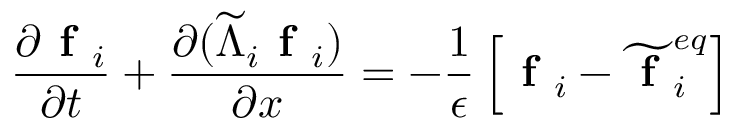<formula> <loc_0><loc_0><loc_500><loc_500>\frac { \partial f _ { i } } { \partial t } + \frac { \partial ( \widetilde { \Lambda } _ { i } f _ { i } ) } { \partial x } = - \frac { 1 } { \epsilon } \left [ f _ { i } - \widetilde { f } _ { i } ^ { e q } \right ]</formula> 